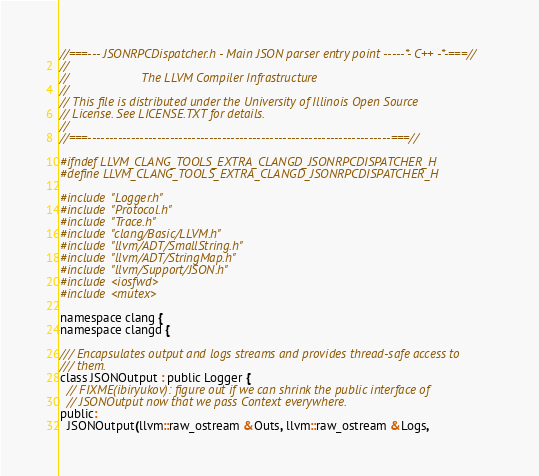<code> <loc_0><loc_0><loc_500><loc_500><_C_>//===--- JSONRPCDispatcher.h - Main JSON parser entry point -----*- C++ -*-===//
//
//                     The LLVM Compiler Infrastructure
//
// This file is distributed under the University of Illinois Open Source
// License. See LICENSE.TXT for details.
//
//===----------------------------------------------------------------------===//

#ifndef LLVM_CLANG_TOOLS_EXTRA_CLANGD_JSONRPCDISPATCHER_H
#define LLVM_CLANG_TOOLS_EXTRA_CLANGD_JSONRPCDISPATCHER_H

#include "Logger.h"
#include "Protocol.h"
#include "Trace.h"
#include "clang/Basic/LLVM.h"
#include "llvm/ADT/SmallString.h"
#include "llvm/ADT/StringMap.h"
#include "llvm/Support/JSON.h"
#include <iosfwd>
#include <mutex>

namespace clang {
namespace clangd {

/// Encapsulates output and logs streams and provides thread-safe access to
/// them.
class JSONOutput : public Logger {
  // FIXME(ibiryukov): figure out if we can shrink the public interface of
  // JSONOutput now that we pass Context everywhere.
public:
  JSONOutput(llvm::raw_ostream &Outs, llvm::raw_ostream &Logs,</code> 